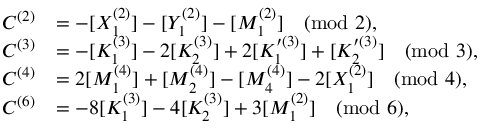Convert formula to latex. <formula><loc_0><loc_0><loc_500><loc_500>\begin{array} { r l } { C ^ { ( 2 ) } } & { = - [ X _ { 1 } ^ { ( 2 ) } ] - [ Y _ { 1 } ^ { ( 2 ) } ] - [ M _ { 1 } ^ { ( 2 ) } ] \pmod { 2 } , } \\ { C ^ { ( 3 ) } } & { = - [ K _ { 1 } ^ { ( 3 ) } ] - 2 [ K _ { 2 } ^ { ( 3 ) } ] + 2 [ K _ { 1 } ^ { \prime ( 3 ) } ] + [ K _ { 2 } ^ { \prime ( 3 ) } ] \pmod { 3 } , } \\ { C ^ { ( 4 ) } } & { = 2 [ M _ { 1 } ^ { ( 4 ) } ] + [ M _ { 2 } ^ { ( 4 ) } ] - [ M _ { 4 } ^ { ( 4 ) } ] - 2 [ X _ { 1 } ^ { ( 2 ) } ] \pmod { 4 } , } \\ { C ^ { ( 6 ) } } & { = - 8 [ K _ { 1 } ^ { ( 3 ) } ] - 4 [ K _ { 2 } ^ { ( 3 ) } ] + 3 [ M _ { 1 } ^ { ( 2 ) } ] \pmod { 6 } , } \end{array}</formula> 